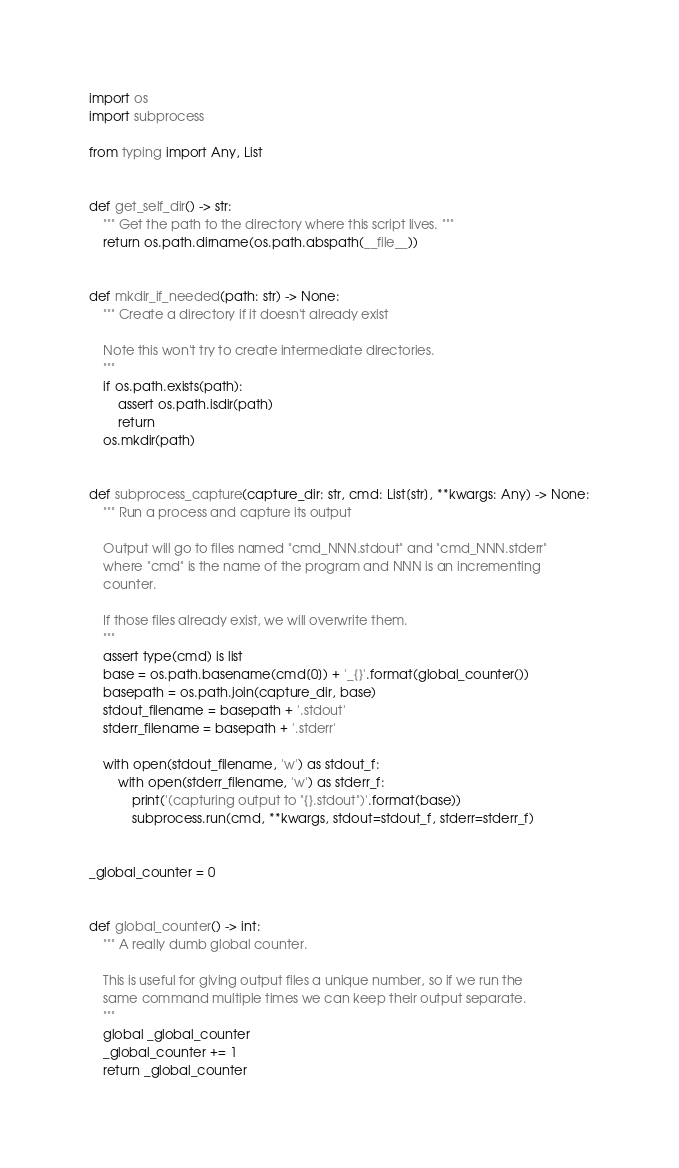Convert code to text. <code><loc_0><loc_0><loc_500><loc_500><_Python_>import os
import subprocess

from typing import Any, List


def get_self_dir() -> str:
    """ Get the path to the directory where this script lives. """
    return os.path.dirname(os.path.abspath(__file__))


def mkdir_if_needed(path: str) -> None:
    """ Create a directory if it doesn't already exist

    Note this won't try to create intermediate directories.
    """
    if os.path.exists(path):
        assert os.path.isdir(path)
        return
    os.mkdir(path)


def subprocess_capture(capture_dir: str, cmd: List[str], **kwargs: Any) -> None:
    """ Run a process and capture its output

    Output will go to files named "cmd_NNN.stdout" and "cmd_NNN.stderr"
    where "cmd" is the name of the program and NNN is an incrementing
    counter.

    If those files already exist, we will overwrite them.
    """
    assert type(cmd) is list
    base = os.path.basename(cmd[0]) + '_{}'.format(global_counter())
    basepath = os.path.join(capture_dir, base)
    stdout_filename = basepath + '.stdout'
    stderr_filename = basepath + '.stderr'

    with open(stdout_filename, 'w') as stdout_f:
        with open(stderr_filename, 'w') as stderr_f:
            print('(capturing output to "{}.stdout")'.format(base))
            subprocess.run(cmd, **kwargs, stdout=stdout_f, stderr=stderr_f)


_global_counter = 0


def global_counter() -> int:
    """ A really dumb global counter.

    This is useful for giving output files a unique number, so if we run the
    same command multiple times we can keep their output separate.
    """
    global _global_counter
    _global_counter += 1
    return _global_counter
</code> 